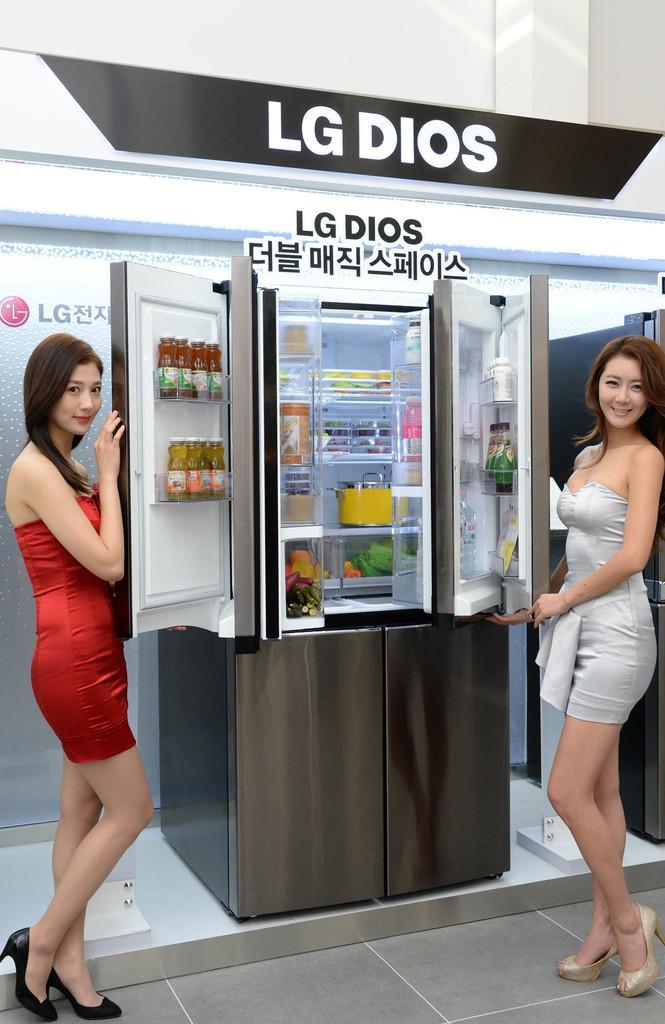Describe this image in one or two sentences. On the left side a beautiful woman is standing, she wore a red color dress. On the right side another beautiful woman is opening the fridge door, she wore white color dress, in the middle there is a fridge there are things in it. 